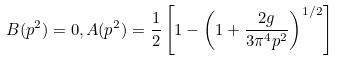<formula> <loc_0><loc_0><loc_500><loc_500>B ( p ^ { 2 } ) = 0 , A ( p ^ { 2 } ) = \frac { 1 } { 2 } \left [ 1 - \left ( 1 + \frac { 2 g } { 3 \pi ^ { 4 } p ^ { 2 } } \right ) ^ { 1 / 2 } \right ]</formula> 